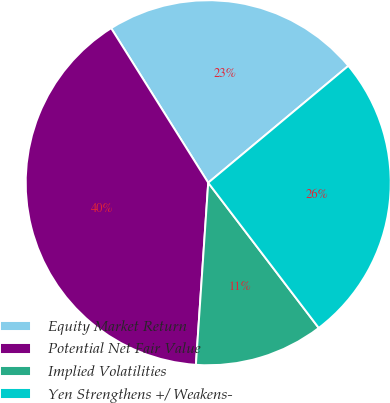Convert chart. <chart><loc_0><loc_0><loc_500><loc_500><pie_chart><fcel>Equity Market Return<fcel>Potential Net Fair Value<fcel>Implied Volatilities<fcel>Yen Strengthens +/ Weakens-<nl><fcel>22.86%<fcel>40.0%<fcel>11.43%<fcel>25.71%<nl></chart> 